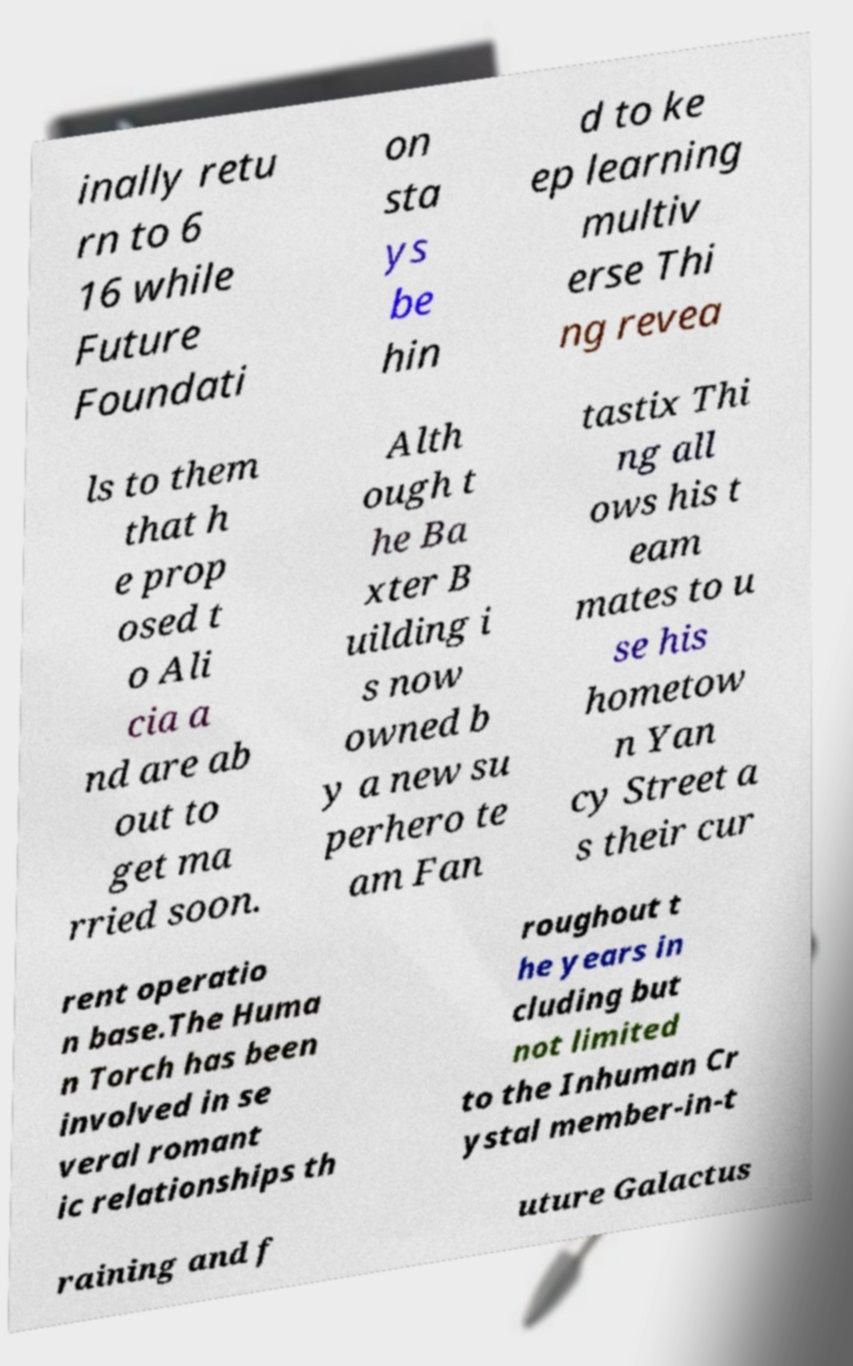Could you assist in decoding the text presented in this image and type it out clearly? inally retu rn to 6 16 while Future Foundati on sta ys be hin d to ke ep learning multiv erse Thi ng revea ls to them that h e prop osed t o Ali cia a nd are ab out to get ma rried soon. Alth ough t he Ba xter B uilding i s now owned b y a new su perhero te am Fan tastix Thi ng all ows his t eam mates to u se his hometow n Yan cy Street a s their cur rent operatio n base.The Huma n Torch has been involved in se veral romant ic relationships th roughout t he years in cluding but not limited to the Inhuman Cr ystal member-in-t raining and f uture Galactus 